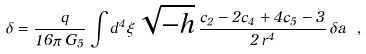Convert formula to latex. <formula><loc_0><loc_0><loc_500><loc_500>\delta = \frac { \ q } { 1 6 \pi \, G _ { 5 } } \int d ^ { 4 } \xi \, \sqrt { - h } \, \frac { c _ { 2 } - 2 c _ { 4 } + 4 c _ { 5 } - 3 } { 2 \, r ^ { 4 } } \, \delta a \ ,</formula> 